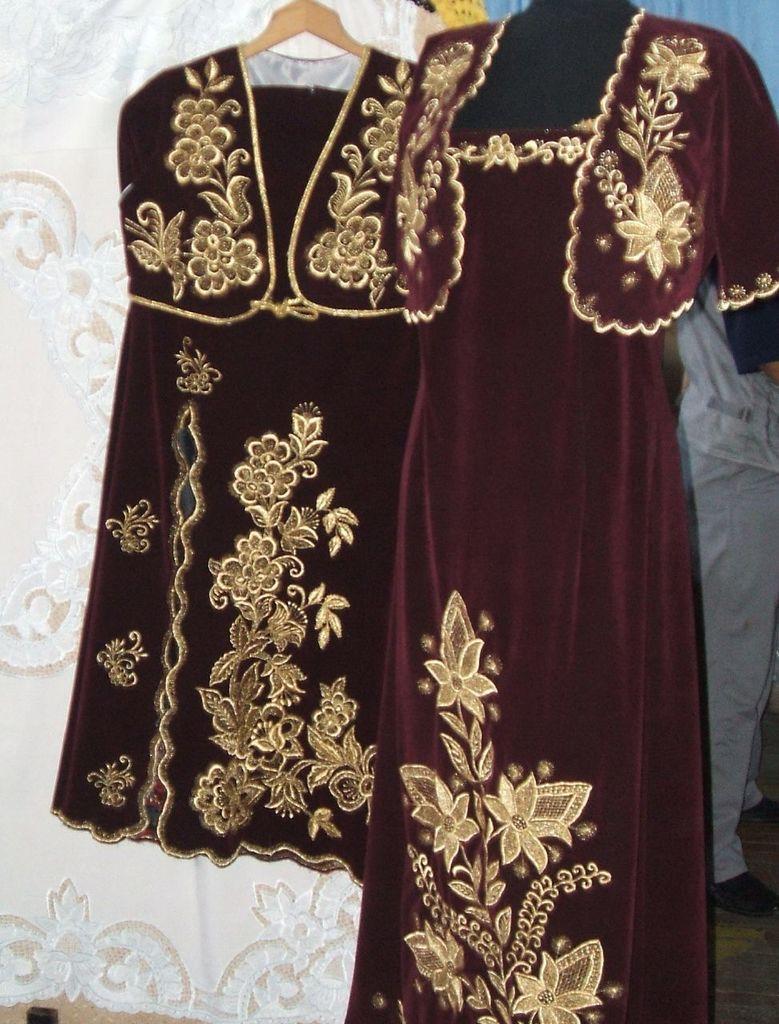Could you give a brief overview of what you see in this image? In the center of the image we can see dresses hanging to the hanger. On the right there is a person standing. 